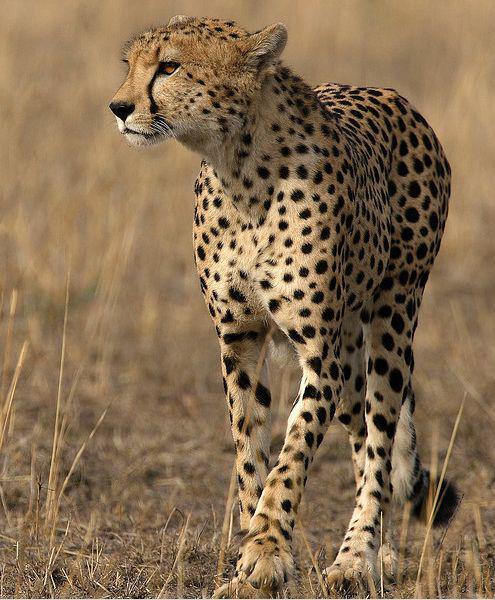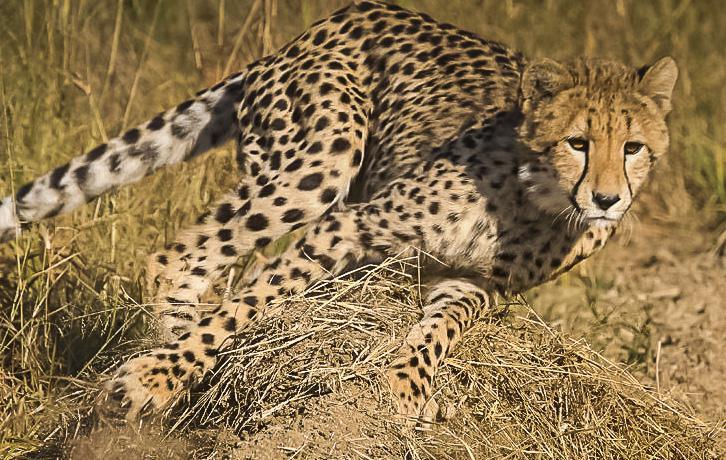The first image is the image on the left, the second image is the image on the right. Examine the images to the left and right. Is the description "At least one cheetah is laying down." accurate? Answer yes or no. No. 